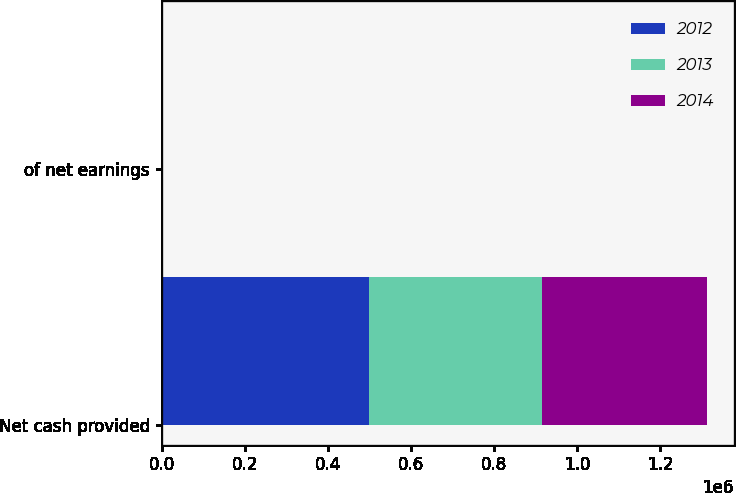Convert chart to OTSL. <chart><loc_0><loc_0><loc_500><loc_500><stacked_bar_chart><ecel><fcel>Net cash provided<fcel>of net earnings<nl><fcel>2012<fcel>499392<fcel>101.1<nl><fcel>2013<fcel>416120<fcel>92.8<nl><fcel>2014<fcel>396292<fcel>94.2<nl></chart> 